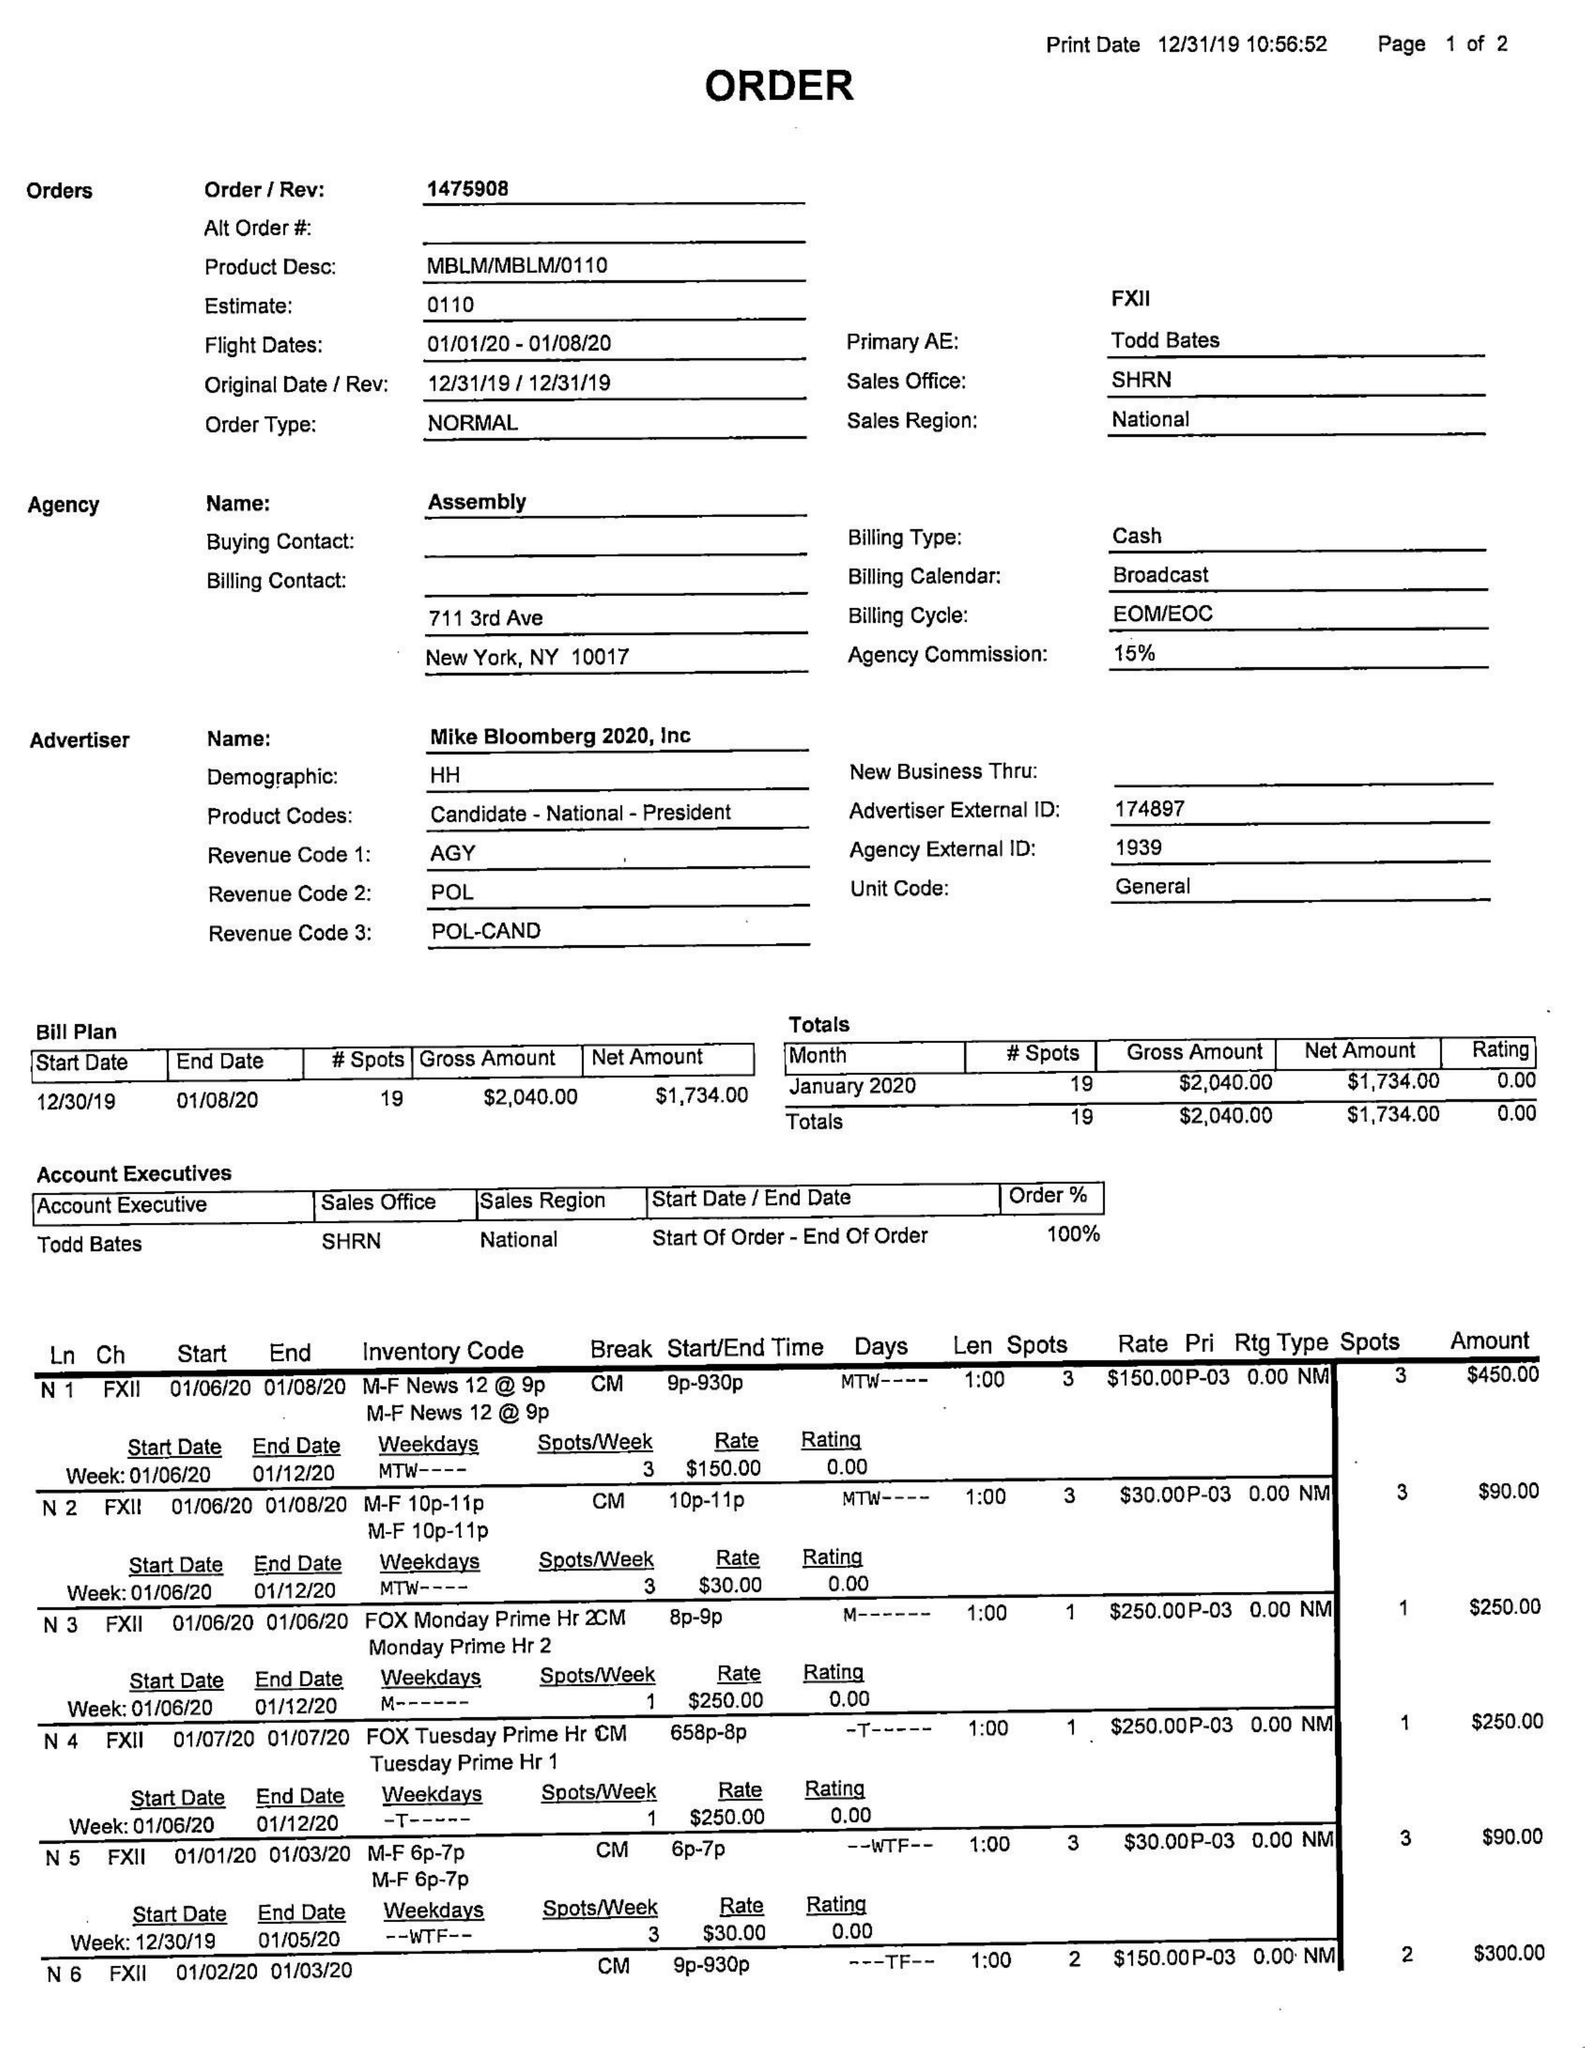What is the value for the gross_amount?
Answer the question using a single word or phrase. 2040.00 